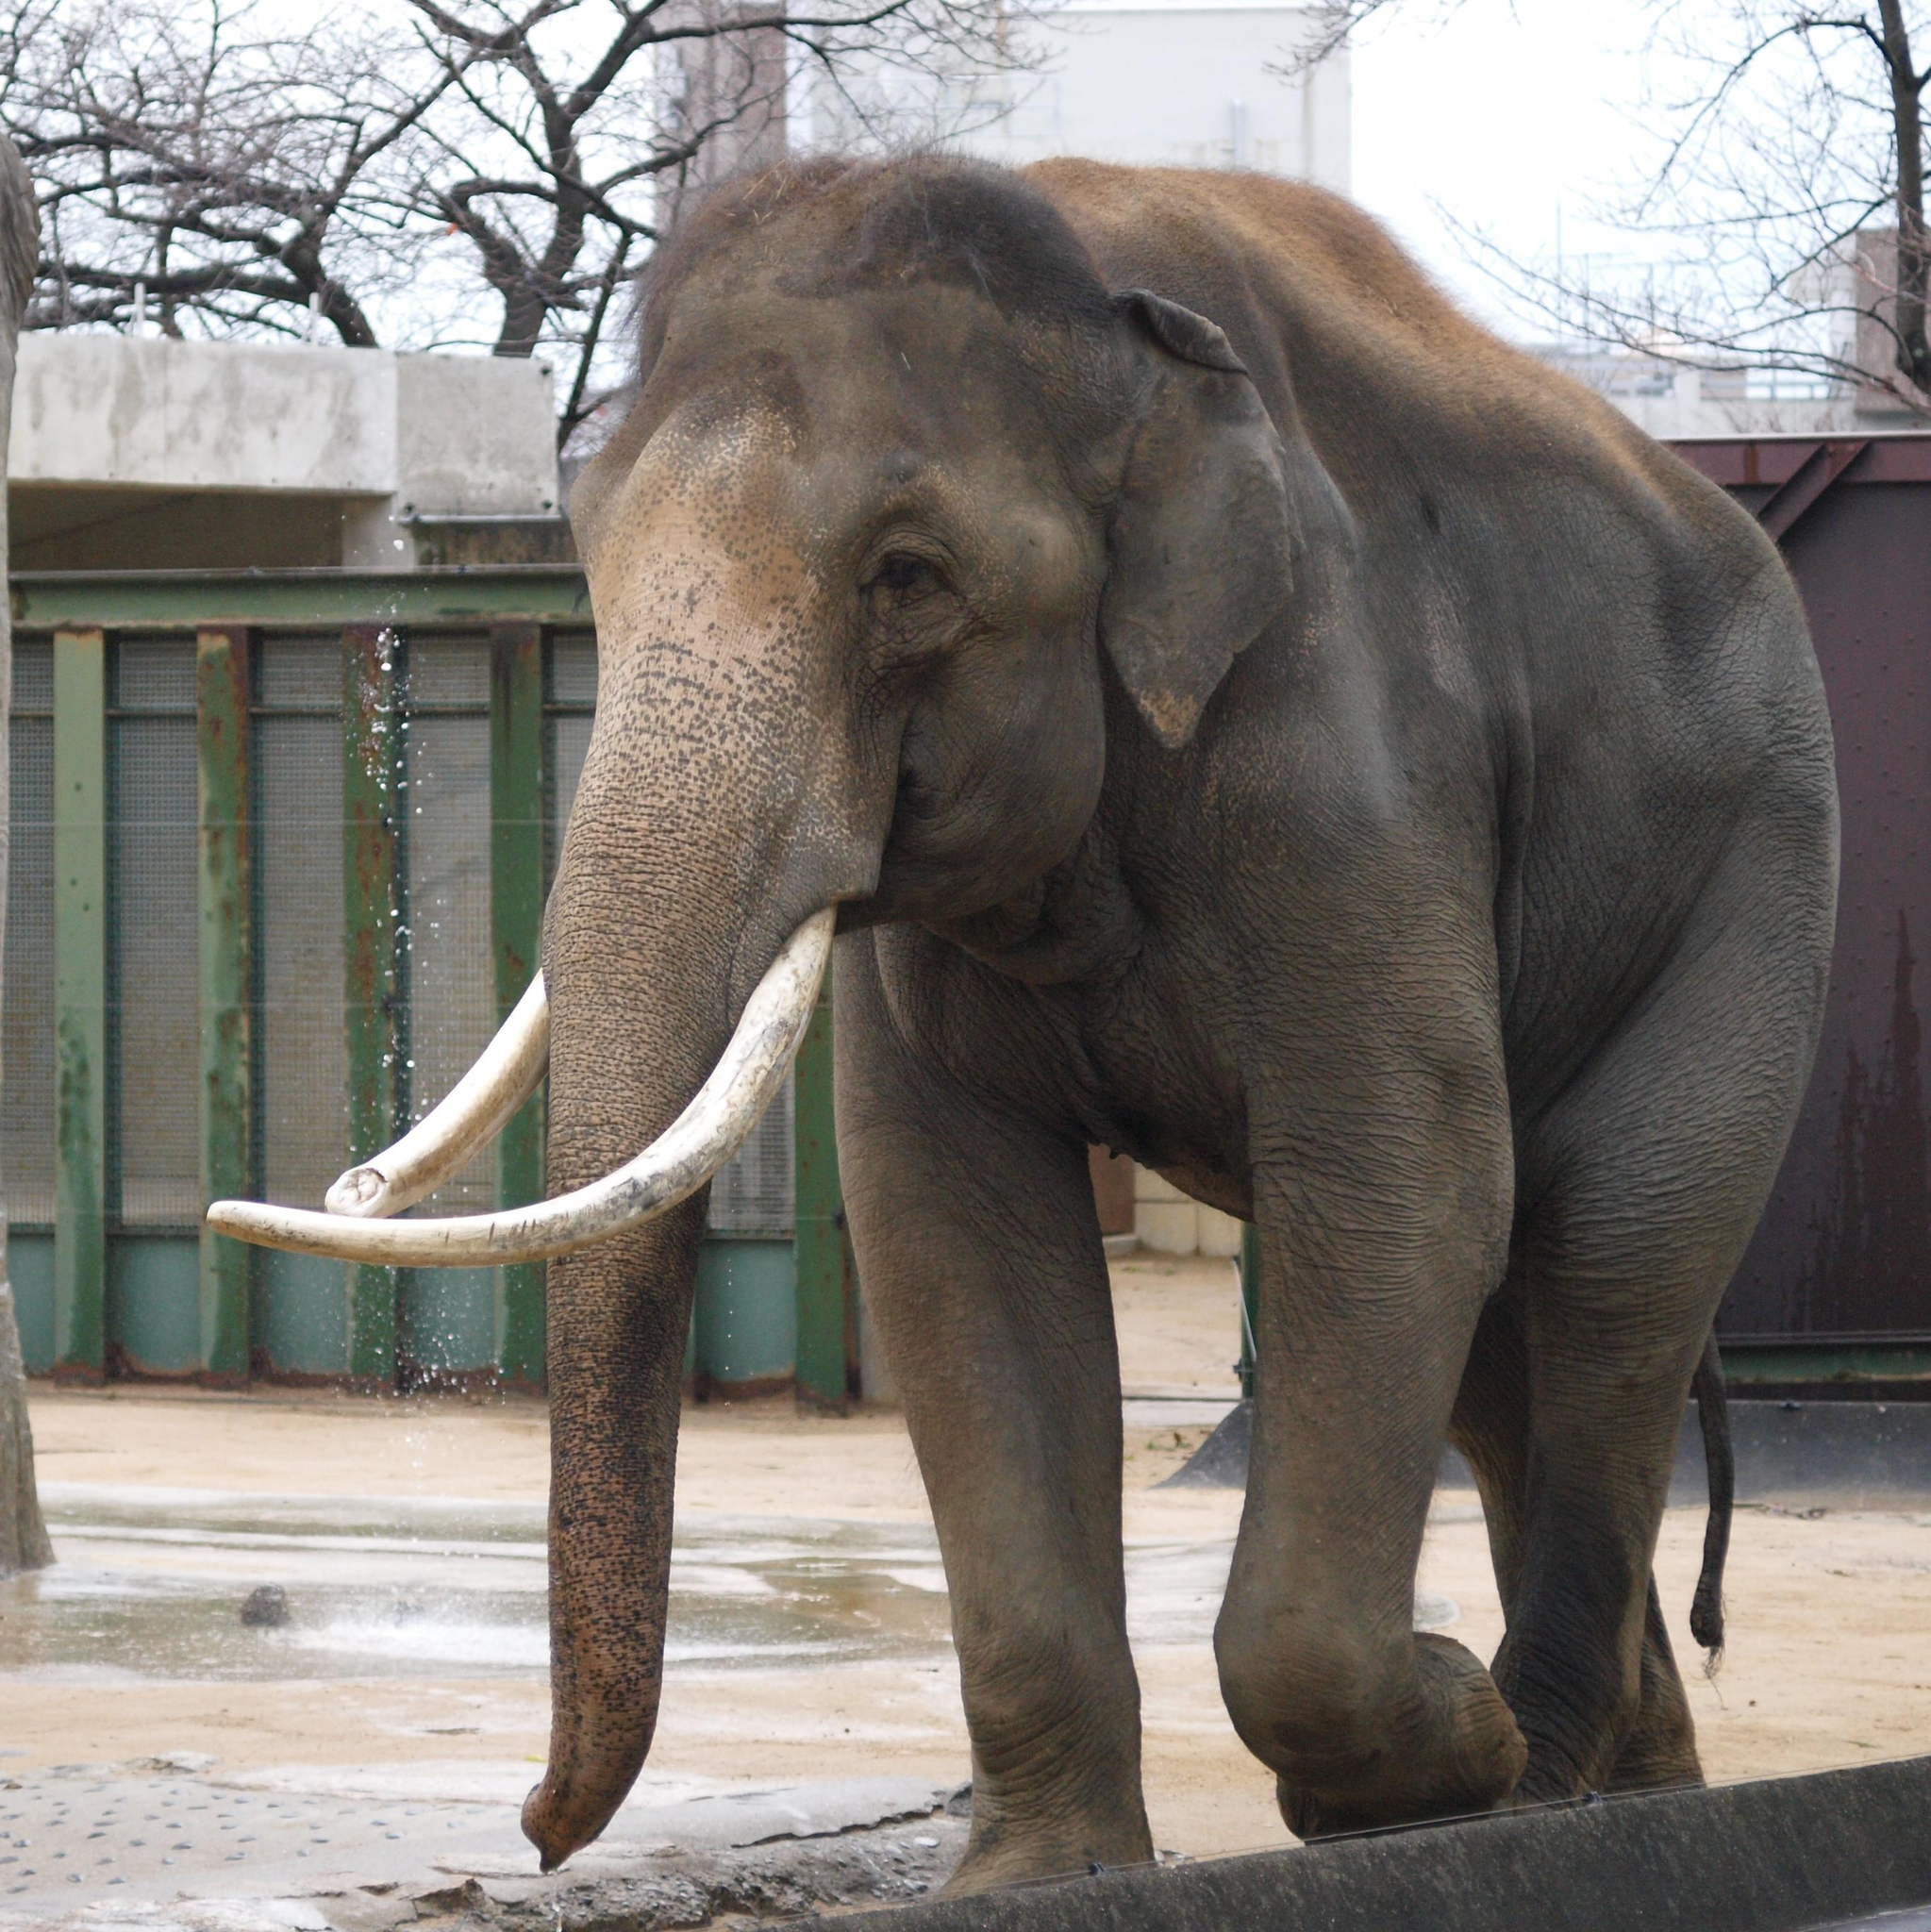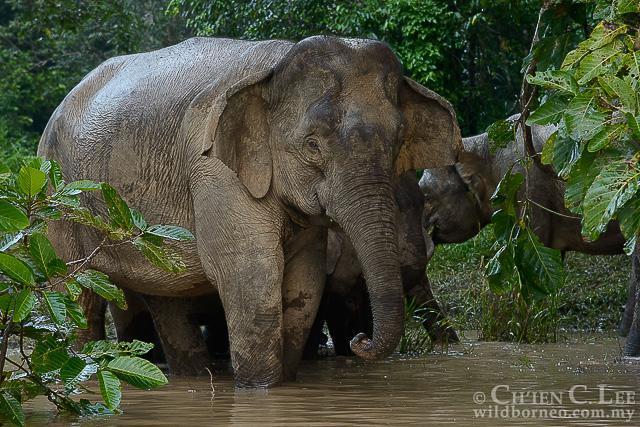The first image is the image on the left, the second image is the image on the right. Considering the images on both sides, is "There are no more than three elephants" valid? Answer yes or no. Yes. 